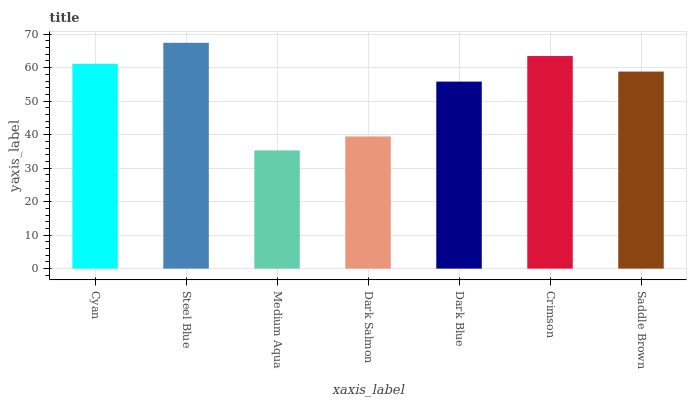Is Medium Aqua the minimum?
Answer yes or no. Yes. Is Steel Blue the maximum?
Answer yes or no. Yes. Is Steel Blue the minimum?
Answer yes or no. No. Is Medium Aqua the maximum?
Answer yes or no. No. Is Steel Blue greater than Medium Aqua?
Answer yes or no. Yes. Is Medium Aqua less than Steel Blue?
Answer yes or no. Yes. Is Medium Aqua greater than Steel Blue?
Answer yes or no. No. Is Steel Blue less than Medium Aqua?
Answer yes or no. No. Is Saddle Brown the high median?
Answer yes or no. Yes. Is Saddle Brown the low median?
Answer yes or no. Yes. Is Medium Aqua the high median?
Answer yes or no. No. Is Cyan the low median?
Answer yes or no. No. 